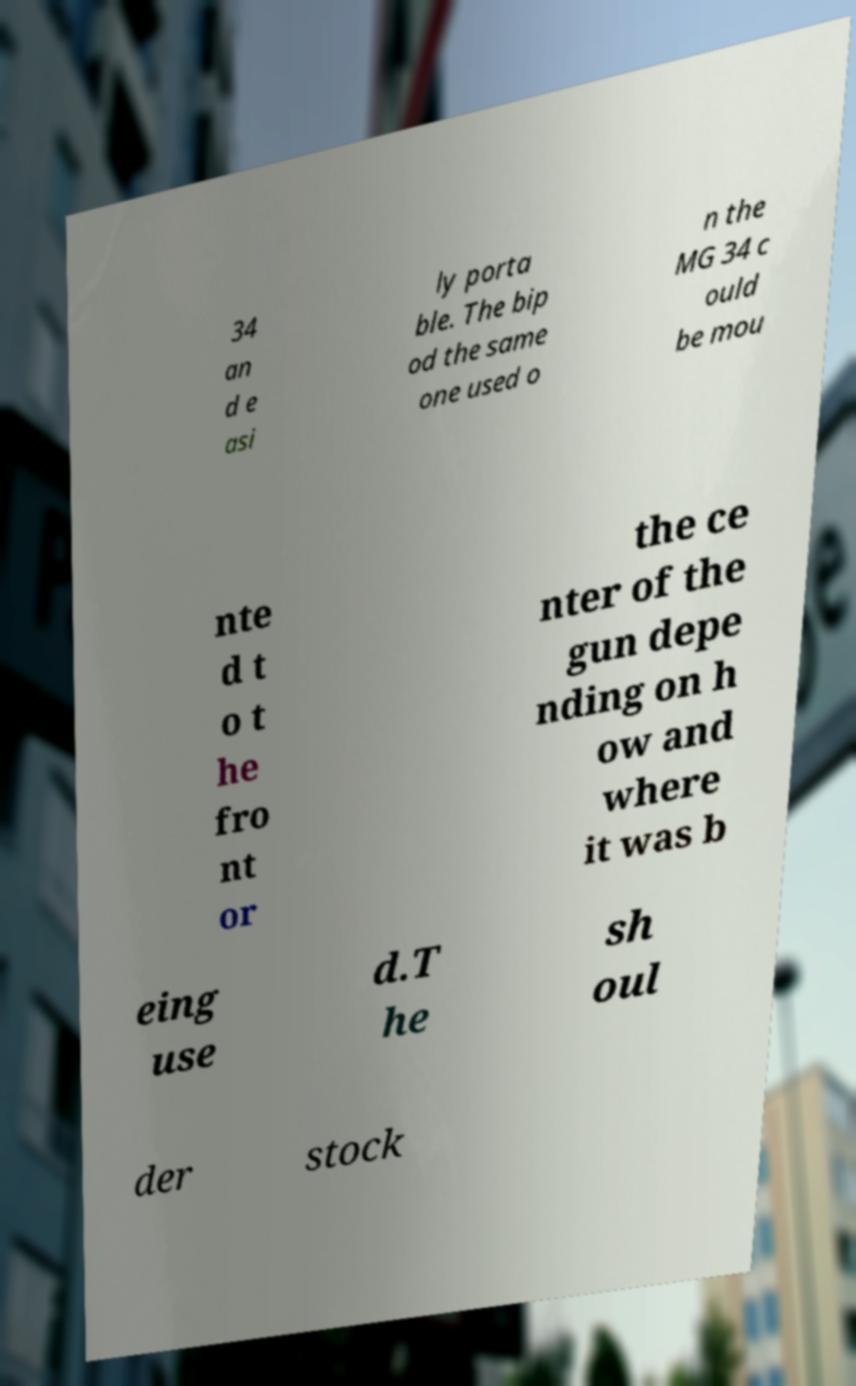Can you read and provide the text displayed in the image?This photo seems to have some interesting text. Can you extract and type it out for me? 34 an d e asi ly porta ble. The bip od the same one used o n the MG 34 c ould be mou nte d t o t he fro nt or the ce nter of the gun depe nding on h ow and where it was b eing use d.T he sh oul der stock 